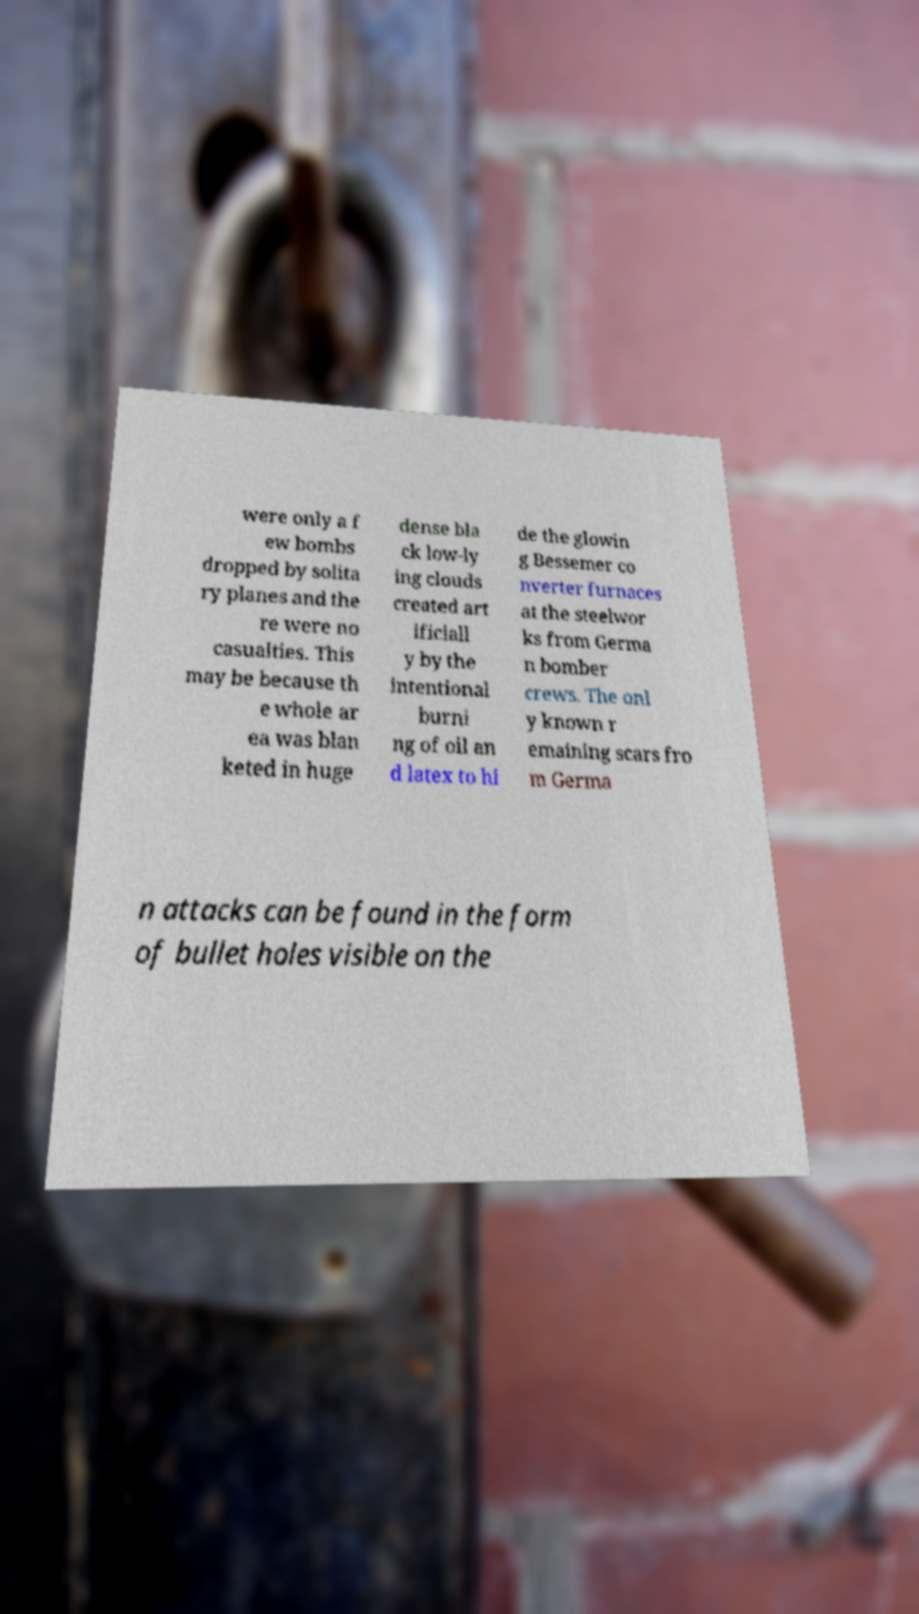Can you accurately transcribe the text from the provided image for me? were only a f ew bombs dropped by solita ry planes and the re were no casualties. This may be because th e whole ar ea was blan keted in huge dense bla ck low-ly ing clouds created art ificiall y by the intentional burni ng of oil an d latex to hi de the glowin g Bessemer co nverter furnaces at the steelwor ks from Germa n bomber crews. The onl y known r emaining scars fro m Germa n attacks can be found in the form of bullet holes visible on the 